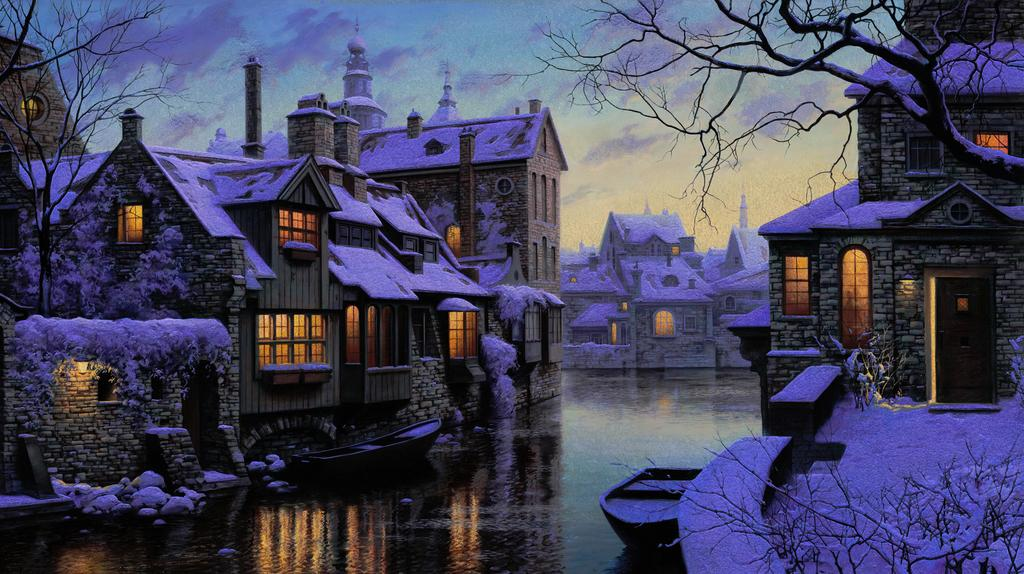What is the condition of the buildings in the image? The buildings in the image are covered by snow. What can be seen at the bottom of the image? There is water visible at the bottom of the image. What is present on the water? Boats are present on the water. What type of vegetation is in the image? There are trees in the image. What is visible in the background of the image? The sky is visible in the background of the image. Is there a beggar asking for beef in the image? There is no beggar or mention of beef in the image. What level of the building is the ice cream shop located on? There is no mention of an ice cream shop or any specific level in the image. 